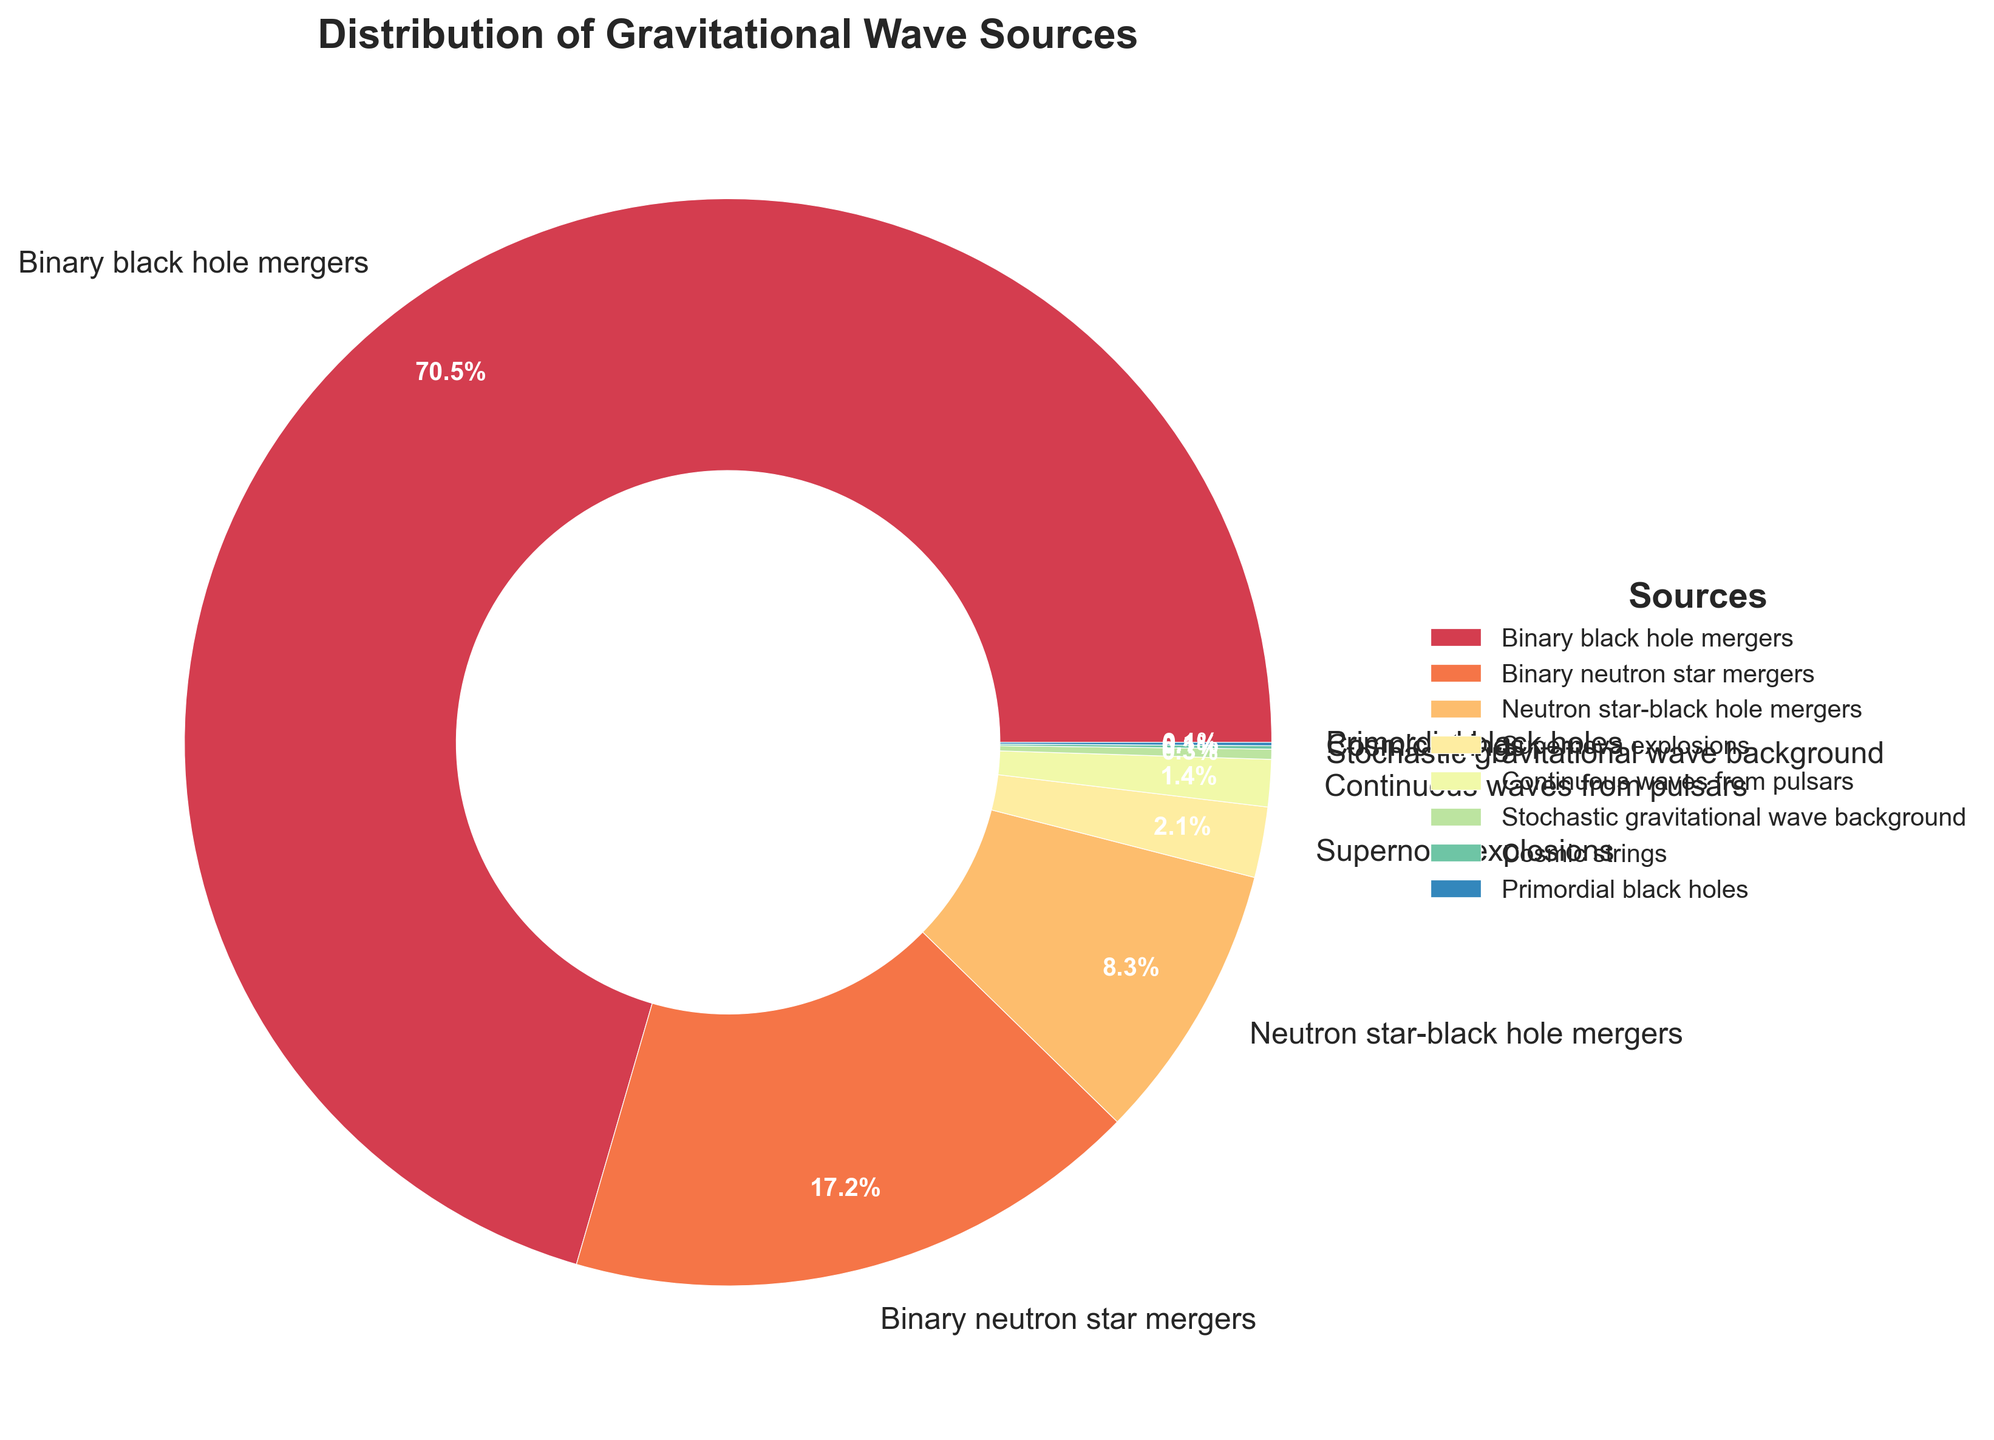What's the most frequently detected source of gravitational waves? The pie chart's largest section represents the most frequently detected source. From the chart, the largest wedge represents binary black hole mergers.
Answer: Binary black hole mergers Which two sources combined contribute to about 25% of the detections? We look at the two wedges whose percentages add up to approximately 25%. Binary neutron star mergers (17.2%) and neutron star-black hole mergers (8.3%) combined contribute to 25.5%.
Answer: Binary neutron star mergers and neutron star-black hole mergers How does the percentage of binary black hole mergers compare to the percentage of supernova explosions? The chart shows a segment representing 70.5% for binary black hole mergers and 2.1% for supernova explosions. Comparing the two, the percentage of binary black hole mergers is much higher.
Answer: Much higher What is the difference in percentage between continuous waves from pulsars and stochastic gravitational wave background? According to the chart, continuous waves from pulsars are 1.4% and stochastic gravitational wave background is 0.3%. The difference is 1.4% - 0.3% = 1.1%.
Answer: 1.1% Which source has the smallest detected percentage, and what is it? The smallest wedge on the pie chart represents the smallest detected percentage. Both cosmic strings and primordial black holes have equal smallest detected percentages of 0.1%.
Answer: Cosmic strings and primordial black holes, 0.1% What percentage of detections are accounted for by sources other than the binary black hole mergers? Binary black hole mergers are 70.5% of the detections. The other sources combined are 100% - 70.5% = 29.5% of the detections.
Answer: 29.5% Which source detection percentage is closer to 10%: neutron star-black hole mergers or continuous waves from pulsars? The percentage for neutron star-black hole mergers is 8.3%, and for continuous waves from pulsars, it is 1.4%. Comparing these, 8.3% is closer to 10% than 1.4%.
Answer: Neutron star-black hole mergers Is the percentage of binary neutron star mergers greater than the sum of stochastic gravitational wave background and cosmic strings? Binary neutron star mergers account for 17.2%, while stochastic gravitational wave background is 0.3% and cosmic strings are 0.1%. Their sum is 0.3% + 0.1% = 0.4%, which is much less than 17.2%.
Answer: Yes Among the nondominant sources (excluding binary black hole mergers), which one has the highest percentage? Excluding binary black hole mergers (70.5%), we look at the remaining wedges. Binary neutron star mergers have the next highest percentage at 17.2%.
Answer: Binary neutron star mergers How does the proportion of binary neutron star mergers compare to cosmic strings and primordial black holes combined? Binary neutron star mergers are 17.2%. Both cosmic strings and primordial black holes are 0.1% each, summing up to 0.1% + 0.1% = 0.2%. The proportion of binary neutron star mergers is significantly greater.
Answer: Significantly greater 